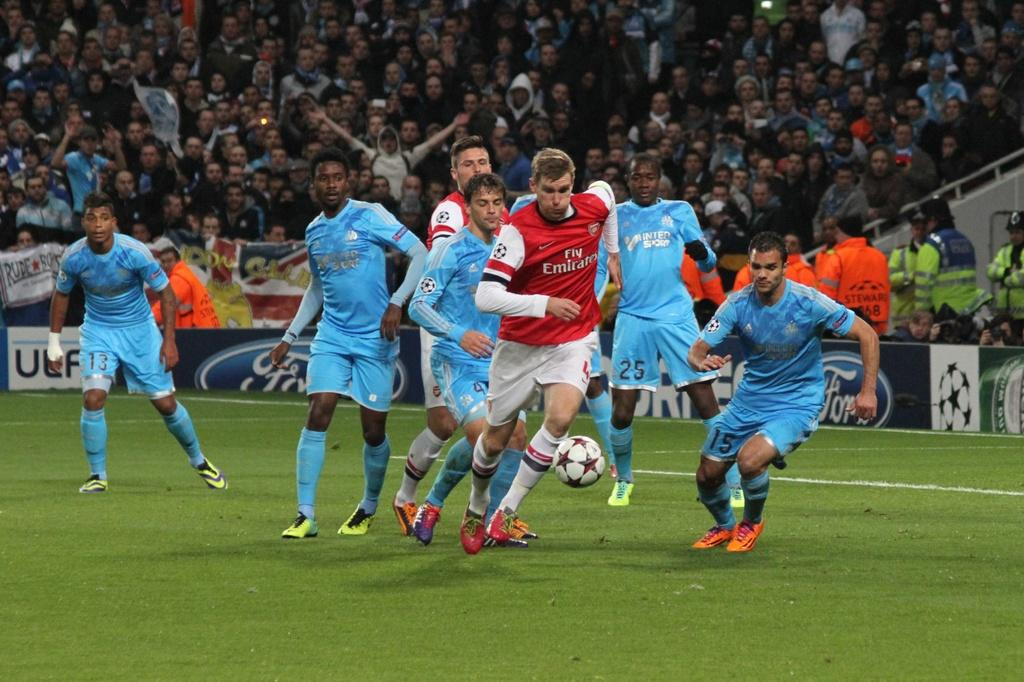What is the main surface visible in the image? There is a ground in the image. What are the people on the ground doing? There are people on the ground, and they are likely playing or engaging in an activity. What object is associated with the activity being performed? There is a football in the image. Can you describe the people in the background of the image? There are people standing in the background of the image. What type of vegetable is being cooked by the people in the image? There is no vegetable or cooking activity present in the image. Can you compare the size of the football to the people in the image? The size of the football in relation to the people cannot be determined from the image alone, as we do not have a reference point for comparison. 